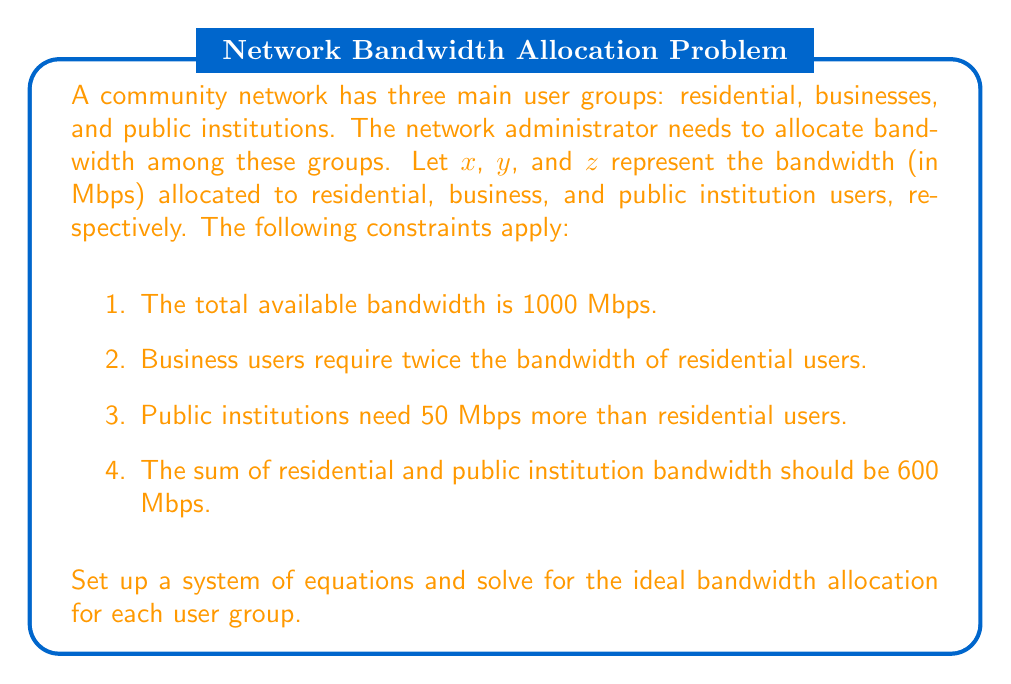Teach me how to tackle this problem. Let's set up the system of equations based on the given constraints:

1. Total bandwidth: $x + y + z = 1000$
2. Business bandwidth: $y = 2x$
3. Public institution bandwidth: $z = x + 50$
4. Sum of residential and public institution bandwidth: $x + z = 600$

Now, let's solve the system step by step:

1. Substitute $z = x + 50$ into the equation $x + z = 600$:
   $x + (x + 50) = 600$
   $2x + 50 = 600$
   $2x = 550$
   $x = 275$

2. Calculate $z$ using $z = x + 50$:
   $z = 275 + 50 = 325$

3. Calculate $y$ using $y = 2x$:
   $y = 2(275) = 550$

4. Verify the total bandwidth:
   $x + y + z = 275 + 550 + 325 = 1000$

Therefore, the ideal bandwidth allocation is:
- Residential users (x): 275 Mbps
- Business users (y): 550 Mbps
- Public institution users (z): 325 Mbps
Answer: Residential users: 275 Mbps
Business users: 550 Mbps
Public institution users: 325 Mbps 